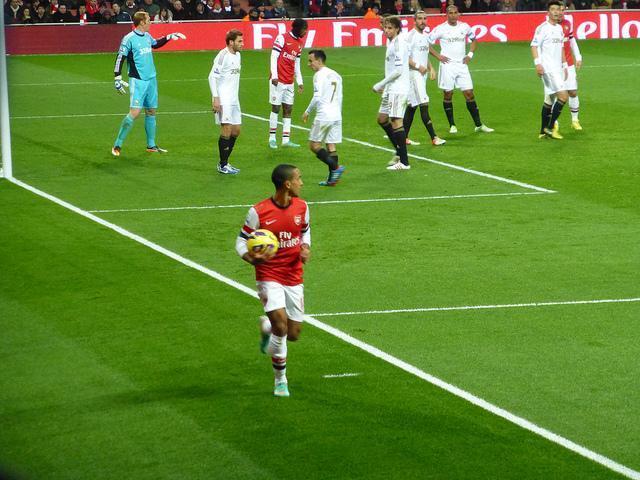How many people can you see?
Give a very brief answer. 9. 